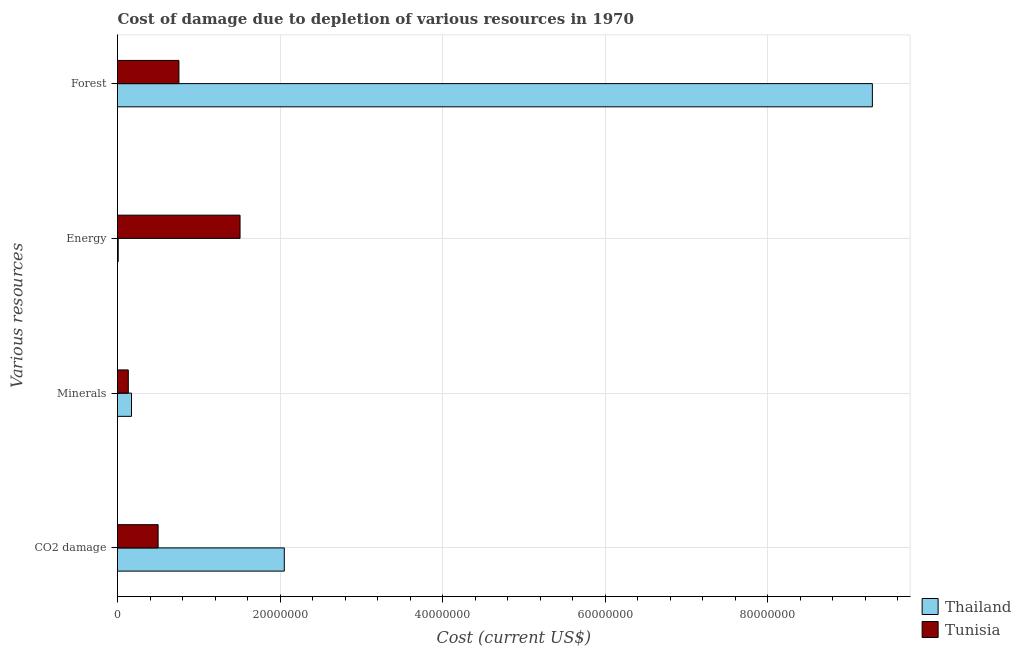How many different coloured bars are there?
Your response must be concise. 2. How many bars are there on the 2nd tick from the bottom?
Provide a succinct answer. 2. What is the label of the 3rd group of bars from the top?
Give a very brief answer. Minerals. What is the cost of damage due to depletion of forests in Thailand?
Ensure brevity in your answer.  9.29e+07. Across all countries, what is the maximum cost of damage due to depletion of energy?
Keep it short and to the point. 1.51e+07. Across all countries, what is the minimum cost of damage due to depletion of minerals?
Keep it short and to the point. 1.33e+06. In which country was the cost of damage due to depletion of forests maximum?
Give a very brief answer. Thailand. In which country was the cost of damage due to depletion of energy minimum?
Your response must be concise. Thailand. What is the total cost of damage due to depletion of coal in the graph?
Your response must be concise. 2.55e+07. What is the difference between the cost of damage due to depletion of coal in Tunisia and that in Thailand?
Provide a succinct answer. -1.55e+07. What is the difference between the cost of damage due to depletion of energy in Tunisia and the cost of damage due to depletion of coal in Thailand?
Your response must be concise. -5.45e+06. What is the average cost of damage due to depletion of energy per country?
Ensure brevity in your answer.  7.58e+06. What is the difference between the cost of damage due to depletion of coal and cost of damage due to depletion of minerals in Thailand?
Your response must be concise. 1.88e+07. What is the ratio of the cost of damage due to depletion of energy in Thailand to that in Tunisia?
Make the answer very short. 0.01. What is the difference between the highest and the second highest cost of damage due to depletion of energy?
Provide a succinct answer. 1.50e+07. What is the difference between the highest and the lowest cost of damage due to depletion of forests?
Your answer should be compact. 8.53e+07. In how many countries, is the cost of damage due to depletion of forests greater than the average cost of damage due to depletion of forests taken over all countries?
Your answer should be compact. 1. Is the sum of the cost of damage due to depletion of coal in Thailand and Tunisia greater than the maximum cost of damage due to depletion of energy across all countries?
Your answer should be very brief. Yes. Is it the case that in every country, the sum of the cost of damage due to depletion of minerals and cost of damage due to depletion of energy is greater than the sum of cost of damage due to depletion of coal and cost of damage due to depletion of forests?
Ensure brevity in your answer.  No. What does the 2nd bar from the top in CO2 damage represents?
Offer a very short reply. Thailand. What does the 1st bar from the bottom in Minerals represents?
Offer a very short reply. Thailand. Is it the case that in every country, the sum of the cost of damage due to depletion of coal and cost of damage due to depletion of minerals is greater than the cost of damage due to depletion of energy?
Your answer should be very brief. No. Are all the bars in the graph horizontal?
Your answer should be compact. Yes. How many countries are there in the graph?
Offer a terse response. 2. Does the graph contain any zero values?
Your answer should be very brief. No. Does the graph contain grids?
Keep it short and to the point. Yes. How many legend labels are there?
Make the answer very short. 2. How are the legend labels stacked?
Your response must be concise. Vertical. What is the title of the graph?
Make the answer very short. Cost of damage due to depletion of various resources in 1970 . Does "Aruba" appear as one of the legend labels in the graph?
Your answer should be very brief. No. What is the label or title of the X-axis?
Provide a short and direct response. Cost (current US$). What is the label or title of the Y-axis?
Make the answer very short. Various resources. What is the Cost (current US$) of Thailand in CO2 damage?
Your answer should be compact. 2.05e+07. What is the Cost (current US$) in Tunisia in CO2 damage?
Give a very brief answer. 5.00e+06. What is the Cost (current US$) of Thailand in Minerals?
Ensure brevity in your answer.  1.72e+06. What is the Cost (current US$) in Tunisia in Minerals?
Make the answer very short. 1.33e+06. What is the Cost (current US$) of Thailand in Energy?
Ensure brevity in your answer.  9.00e+04. What is the Cost (current US$) in Tunisia in Energy?
Make the answer very short. 1.51e+07. What is the Cost (current US$) in Thailand in Forest?
Your answer should be compact. 9.29e+07. What is the Cost (current US$) of Tunisia in Forest?
Give a very brief answer. 7.56e+06. Across all Various resources, what is the maximum Cost (current US$) of Thailand?
Offer a very short reply. 9.29e+07. Across all Various resources, what is the maximum Cost (current US$) of Tunisia?
Provide a short and direct response. 1.51e+07. Across all Various resources, what is the minimum Cost (current US$) of Thailand?
Offer a terse response. 9.00e+04. Across all Various resources, what is the minimum Cost (current US$) in Tunisia?
Ensure brevity in your answer.  1.33e+06. What is the total Cost (current US$) in Thailand in the graph?
Provide a succinct answer. 1.15e+08. What is the total Cost (current US$) in Tunisia in the graph?
Ensure brevity in your answer.  2.90e+07. What is the difference between the Cost (current US$) of Thailand in CO2 damage and that in Minerals?
Provide a short and direct response. 1.88e+07. What is the difference between the Cost (current US$) of Tunisia in CO2 damage and that in Minerals?
Your answer should be compact. 3.67e+06. What is the difference between the Cost (current US$) of Thailand in CO2 damage and that in Energy?
Keep it short and to the point. 2.04e+07. What is the difference between the Cost (current US$) in Tunisia in CO2 damage and that in Energy?
Provide a short and direct response. -1.01e+07. What is the difference between the Cost (current US$) of Thailand in CO2 damage and that in Forest?
Make the answer very short. -7.24e+07. What is the difference between the Cost (current US$) in Tunisia in CO2 damage and that in Forest?
Provide a succinct answer. -2.56e+06. What is the difference between the Cost (current US$) of Thailand in Minerals and that in Energy?
Give a very brief answer. 1.63e+06. What is the difference between the Cost (current US$) of Tunisia in Minerals and that in Energy?
Keep it short and to the point. -1.38e+07. What is the difference between the Cost (current US$) in Thailand in Minerals and that in Forest?
Give a very brief answer. -9.12e+07. What is the difference between the Cost (current US$) in Tunisia in Minerals and that in Forest?
Make the answer very short. -6.23e+06. What is the difference between the Cost (current US$) in Thailand in Energy and that in Forest?
Keep it short and to the point. -9.28e+07. What is the difference between the Cost (current US$) of Tunisia in Energy and that in Forest?
Offer a terse response. 7.52e+06. What is the difference between the Cost (current US$) in Thailand in CO2 damage and the Cost (current US$) in Tunisia in Minerals?
Your answer should be very brief. 1.92e+07. What is the difference between the Cost (current US$) in Thailand in CO2 damage and the Cost (current US$) in Tunisia in Energy?
Your answer should be compact. 5.45e+06. What is the difference between the Cost (current US$) in Thailand in CO2 damage and the Cost (current US$) in Tunisia in Forest?
Ensure brevity in your answer.  1.30e+07. What is the difference between the Cost (current US$) in Thailand in Minerals and the Cost (current US$) in Tunisia in Energy?
Offer a terse response. -1.34e+07. What is the difference between the Cost (current US$) of Thailand in Minerals and the Cost (current US$) of Tunisia in Forest?
Provide a succinct answer. -5.83e+06. What is the difference between the Cost (current US$) in Thailand in Energy and the Cost (current US$) in Tunisia in Forest?
Provide a succinct answer. -7.47e+06. What is the average Cost (current US$) of Thailand per Various resources?
Your answer should be very brief. 2.88e+07. What is the average Cost (current US$) of Tunisia per Various resources?
Offer a very short reply. 7.24e+06. What is the difference between the Cost (current US$) of Thailand and Cost (current US$) of Tunisia in CO2 damage?
Make the answer very short. 1.55e+07. What is the difference between the Cost (current US$) in Thailand and Cost (current US$) in Tunisia in Minerals?
Offer a very short reply. 3.98e+05. What is the difference between the Cost (current US$) of Thailand and Cost (current US$) of Tunisia in Energy?
Offer a terse response. -1.50e+07. What is the difference between the Cost (current US$) in Thailand and Cost (current US$) in Tunisia in Forest?
Your answer should be compact. 8.53e+07. What is the ratio of the Cost (current US$) in Thailand in CO2 damage to that in Minerals?
Give a very brief answer. 11.9. What is the ratio of the Cost (current US$) in Tunisia in CO2 damage to that in Minerals?
Provide a succinct answer. 3.77. What is the ratio of the Cost (current US$) in Thailand in CO2 damage to that in Energy?
Ensure brevity in your answer.  228.12. What is the ratio of the Cost (current US$) in Tunisia in CO2 damage to that in Energy?
Provide a short and direct response. 0.33. What is the ratio of the Cost (current US$) in Thailand in CO2 damage to that in Forest?
Provide a succinct answer. 0.22. What is the ratio of the Cost (current US$) in Tunisia in CO2 damage to that in Forest?
Offer a terse response. 0.66. What is the ratio of the Cost (current US$) of Thailand in Minerals to that in Energy?
Keep it short and to the point. 19.17. What is the ratio of the Cost (current US$) in Tunisia in Minerals to that in Energy?
Provide a short and direct response. 0.09. What is the ratio of the Cost (current US$) of Thailand in Minerals to that in Forest?
Make the answer very short. 0.02. What is the ratio of the Cost (current US$) of Tunisia in Minerals to that in Forest?
Provide a succinct answer. 0.18. What is the ratio of the Cost (current US$) of Tunisia in Energy to that in Forest?
Keep it short and to the point. 2. What is the difference between the highest and the second highest Cost (current US$) of Thailand?
Your response must be concise. 7.24e+07. What is the difference between the highest and the second highest Cost (current US$) of Tunisia?
Your answer should be very brief. 7.52e+06. What is the difference between the highest and the lowest Cost (current US$) of Thailand?
Keep it short and to the point. 9.28e+07. What is the difference between the highest and the lowest Cost (current US$) of Tunisia?
Offer a terse response. 1.38e+07. 